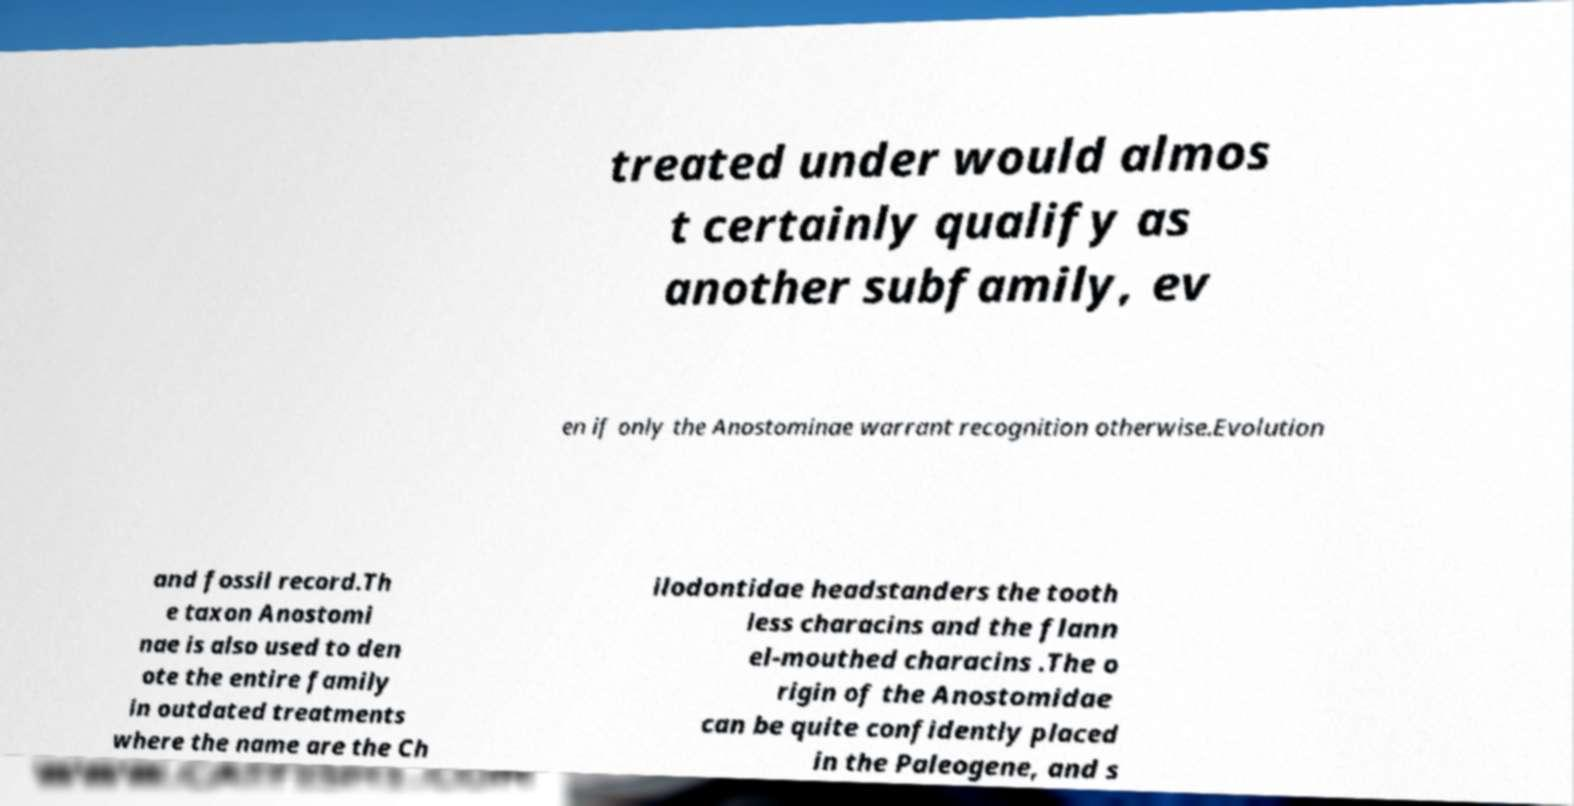Can you accurately transcribe the text from the provided image for me? treated under would almos t certainly qualify as another subfamily, ev en if only the Anostominae warrant recognition otherwise.Evolution and fossil record.Th e taxon Anostomi nae is also used to den ote the entire family in outdated treatments where the name are the Ch ilodontidae headstanders the tooth less characins and the flann el-mouthed characins .The o rigin of the Anostomidae can be quite confidently placed in the Paleogene, and s 